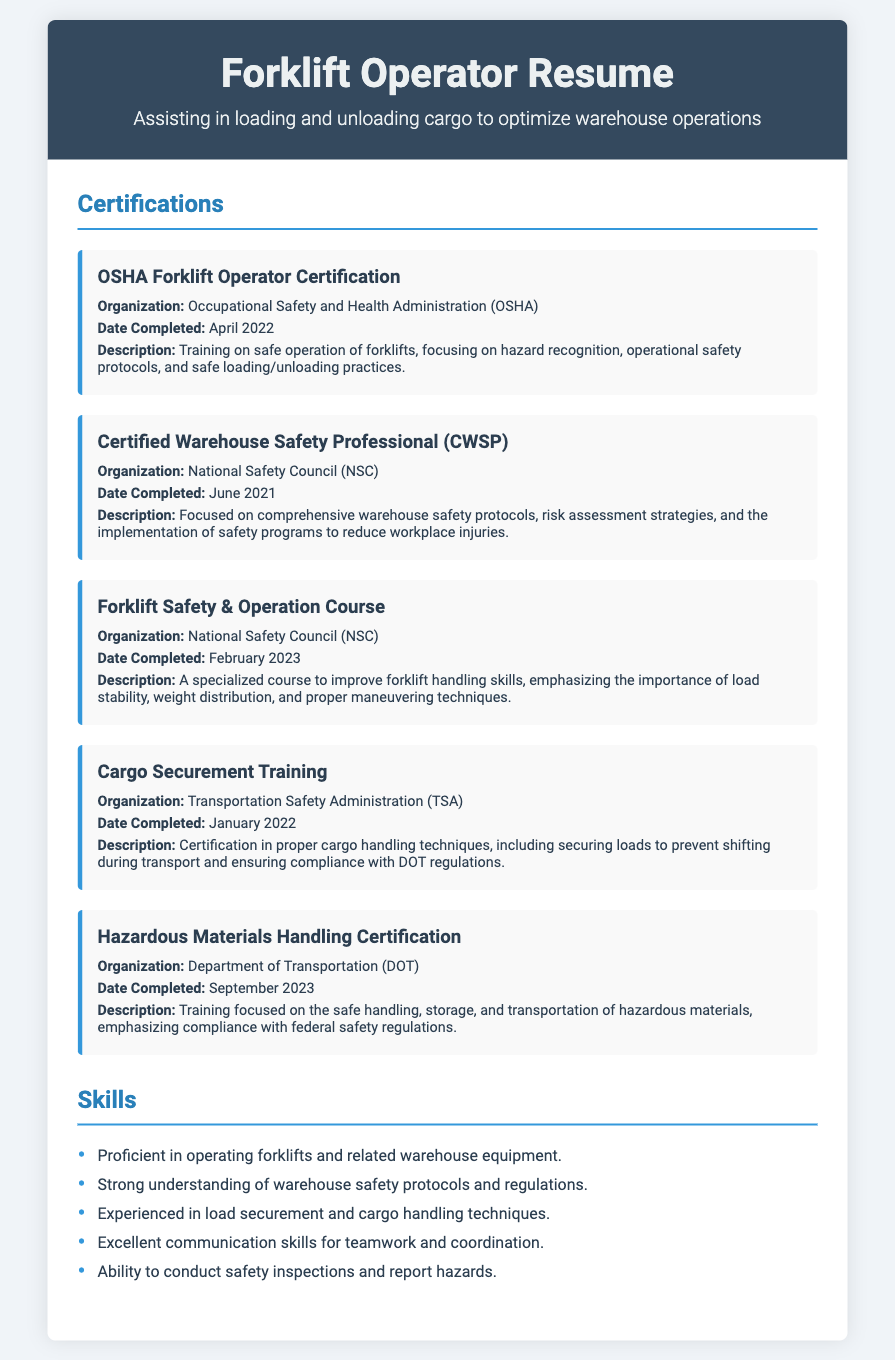What is the organization's name for the Forklift Safety & Operation Course? The organization name listed in the document is National Safety Council (NSC).
Answer: National Safety Council (NSC) When was the Hazardous Materials Handling Certification completed? The completion date for the Hazardous Materials Handling Certification is provided in the document.
Answer: September 2023 What type of training is included in the OSHA Forklift Operator Certification? The type of training focuses on safe operation of forklifts, hazard recognition, operational safety protocols, and loading/unloading practices.
Answer: Safe operation of forklifts Who issued the Certified Warehouse Safety Professional certification? The document states the organization that issued this certification.
Answer: National Safety Council (NSC) What year was the Cargo Securement Training completed? The document specifies the completion year for the Cargo Securement Training.
Answer: 2022 What is emphasized in the Forklift Safety & Operation Course? Key elements mentioned in the course description include load stability, weight distribution, and proper maneuvering techniques.
Answer: Load stability, weight distribution, and proper maneuvering techniques What kind of materials does the Hazardous Materials Handling Certification focus on? The certification focuses specifically on the safe handling, storage, and transportation of hazardous materials.
Answer: Hazardous materials How many certifications are listed in the document? The total number of certifications mentioned in the document is counted.
Answer: Five 